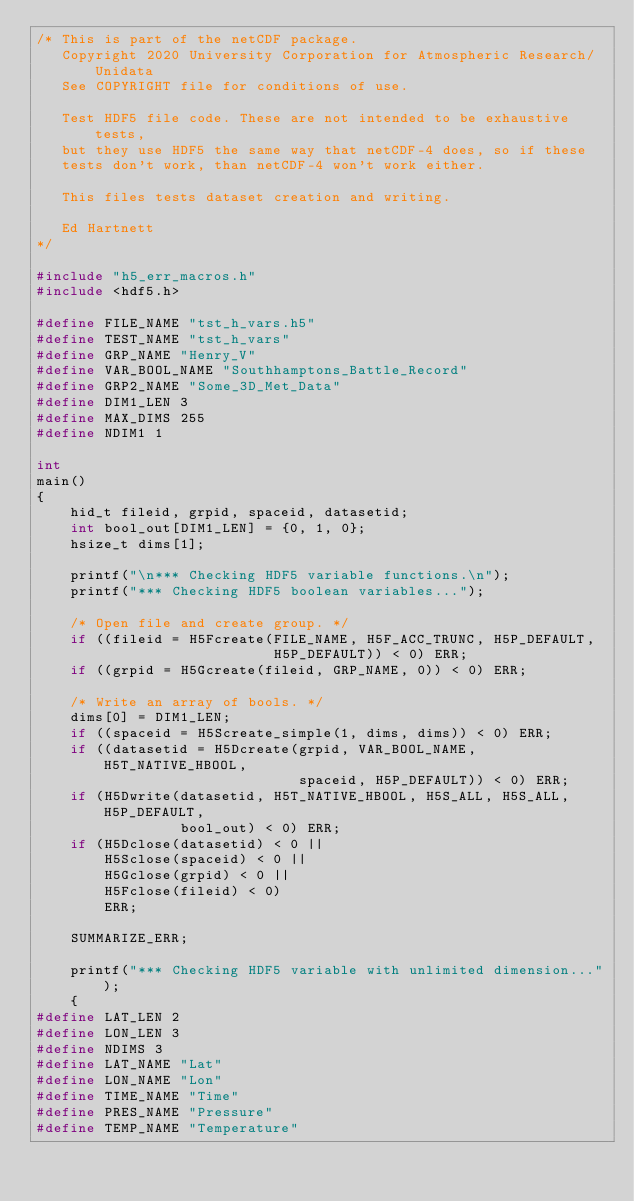<code> <loc_0><loc_0><loc_500><loc_500><_C_>/* This is part of the netCDF package.
   Copyright 2020 University Corporation for Atmospheric Research/Unidata
   See COPYRIGHT file for conditions of use.

   Test HDF5 file code. These are not intended to be exhaustive tests,
   but they use HDF5 the same way that netCDF-4 does, so if these
   tests don't work, than netCDF-4 won't work either.

   This files tests dataset creation and writing.

   Ed Hartnett
*/

#include "h5_err_macros.h"
#include <hdf5.h>

#define FILE_NAME "tst_h_vars.h5"
#define TEST_NAME "tst_h_vars"
#define GRP_NAME "Henry_V"
#define VAR_BOOL_NAME "Southhamptons_Battle_Record"
#define GRP2_NAME "Some_3D_Met_Data"
#define DIM1_LEN 3
#define MAX_DIMS 255
#define NDIM1 1

int
main()
{
    hid_t fileid, grpid, spaceid, datasetid;
    int bool_out[DIM1_LEN] = {0, 1, 0};
    hsize_t dims[1];

    printf("\n*** Checking HDF5 variable functions.\n");
    printf("*** Checking HDF5 boolean variables...");

    /* Open file and create group. */
    if ((fileid = H5Fcreate(FILE_NAME, H5F_ACC_TRUNC, H5P_DEFAULT,
                            H5P_DEFAULT)) < 0) ERR;
    if ((grpid = H5Gcreate(fileid, GRP_NAME, 0)) < 0) ERR;

    /* Write an array of bools. */
    dims[0] = DIM1_LEN;
    if ((spaceid = H5Screate_simple(1, dims, dims)) < 0) ERR;
    if ((datasetid = H5Dcreate(grpid, VAR_BOOL_NAME, H5T_NATIVE_HBOOL,
                               spaceid, H5P_DEFAULT)) < 0) ERR;
    if (H5Dwrite(datasetid, H5T_NATIVE_HBOOL, H5S_ALL, H5S_ALL, H5P_DEFAULT,
                 bool_out) < 0) ERR;
    if (H5Dclose(datasetid) < 0 ||
        H5Sclose(spaceid) < 0 ||
        H5Gclose(grpid) < 0 ||
        H5Fclose(fileid) < 0)
        ERR;

    SUMMARIZE_ERR;

    printf("*** Checking HDF5 variable with unlimited dimension...");
    {
#define LAT_LEN 2
#define LON_LEN 3
#define NDIMS 3
#define LAT_NAME "Lat"
#define LON_NAME "Lon"
#define TIME_NAME "Time"
#define PRES_NAME "Pressure"
#define TEMP_NAME "Temperature"
</code> 